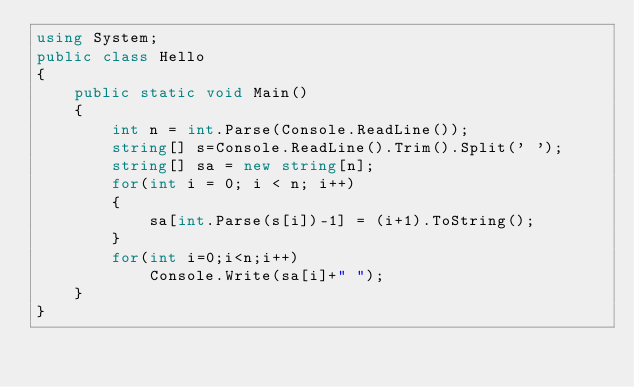Convert code to text. <code><loc_0><loc_0><loc_500><loc_500><_C#_>using System;
public class Hello
{
    public static void Main()
    {
        int n = int.Parse(Console.ReadLine());
        string[] s=Console.ReadLine().Trim().Split(' ');
        string[] sa = new string[n];
        for(int i = 0; i < n; i++)
        {
            sa[int.Parse(s[i])-1] = (i+1).ToString();
        }
        for(int i=0;i<n;i++)
            Console.Write(sa[i]+" ");
    }
}</code> 